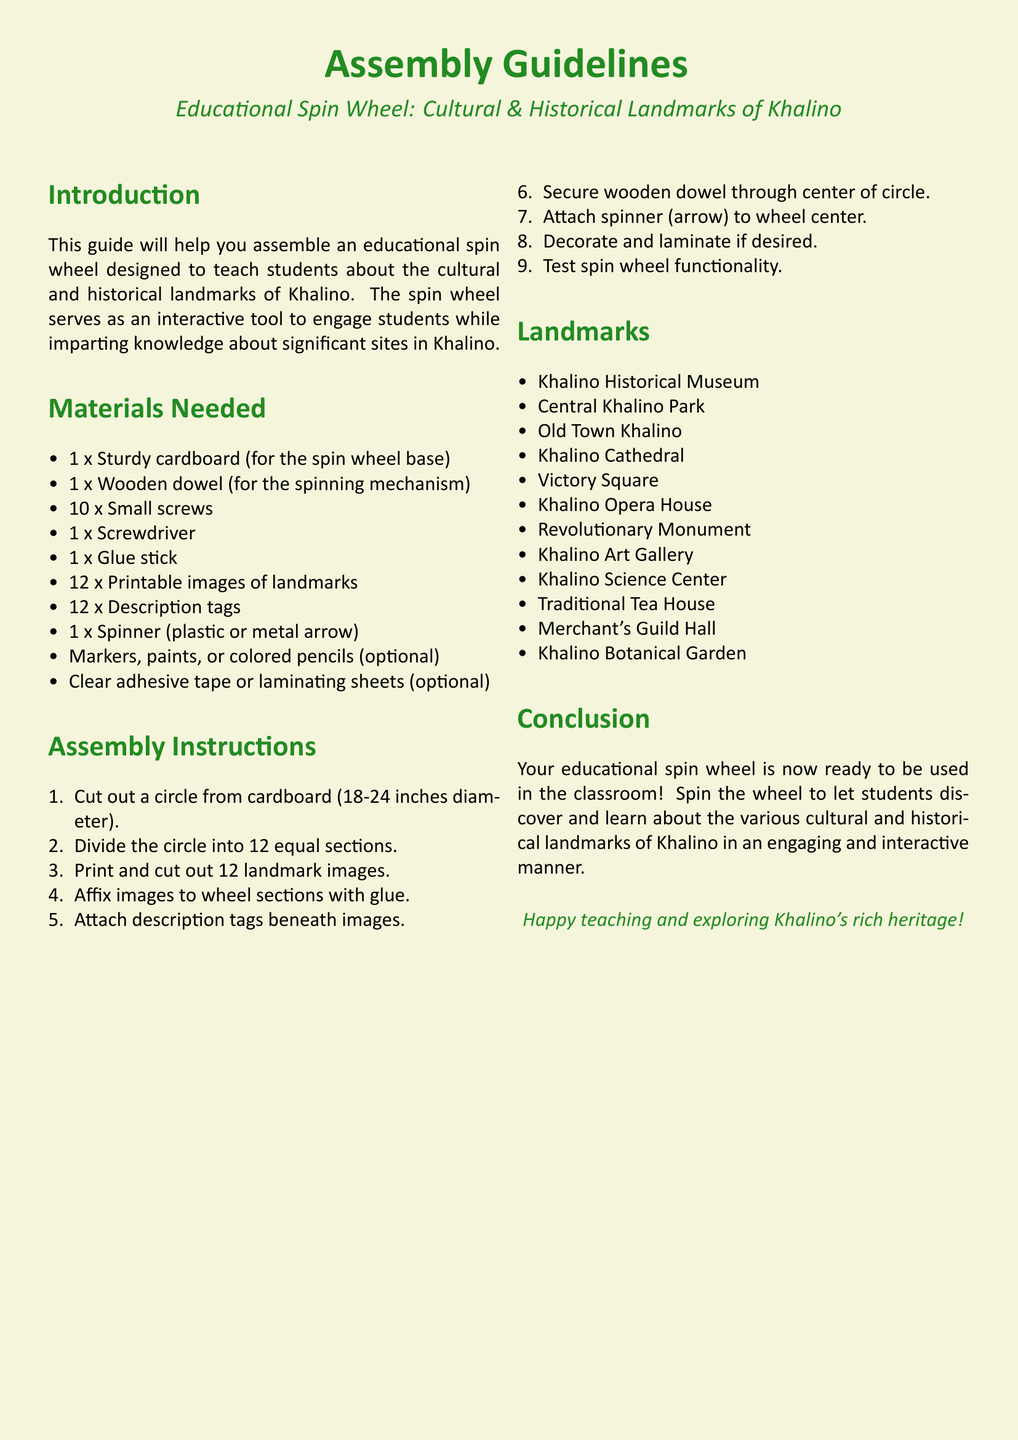What is the diameter of the cardboard circle? The diameter of the cardboard circle is specified in the assembly instructions as being between 18 to 24 inches.
Answer: 18-24 inches How many images of landmarks are needed? The materials list states that 12 printable images of landmarks are required for the spin wheel.
Answer: 12 What color is the background of the document? The document's background color is specified as beige in the setup.
Answer: beige What tool is used to secure the wooden dowel? The materials list indicates that a screwdriver is needed for securing the wooden dowel through the center of the circle.
Answer: screwdriver What is the last step before using the spin wheel? The assembly instructions conclude with testing the spin wheel functionality as the final step.
Answer: Test spin wheel functionality How many equal sections should the wheel be divided into? The instructions state that the cardboard circle should be divided into 12 equal sections.
Answer: 12 Which landmark is mentioned first in the list? The first landmark listed in the document under the landmarks section is the Khalino Historical Museum.
Answer: Khalino Historical Museum What type of educational tool is being created? The spin wheel being assembled is an interactive educational tool designed to teach students.
Answer: spin wheel 